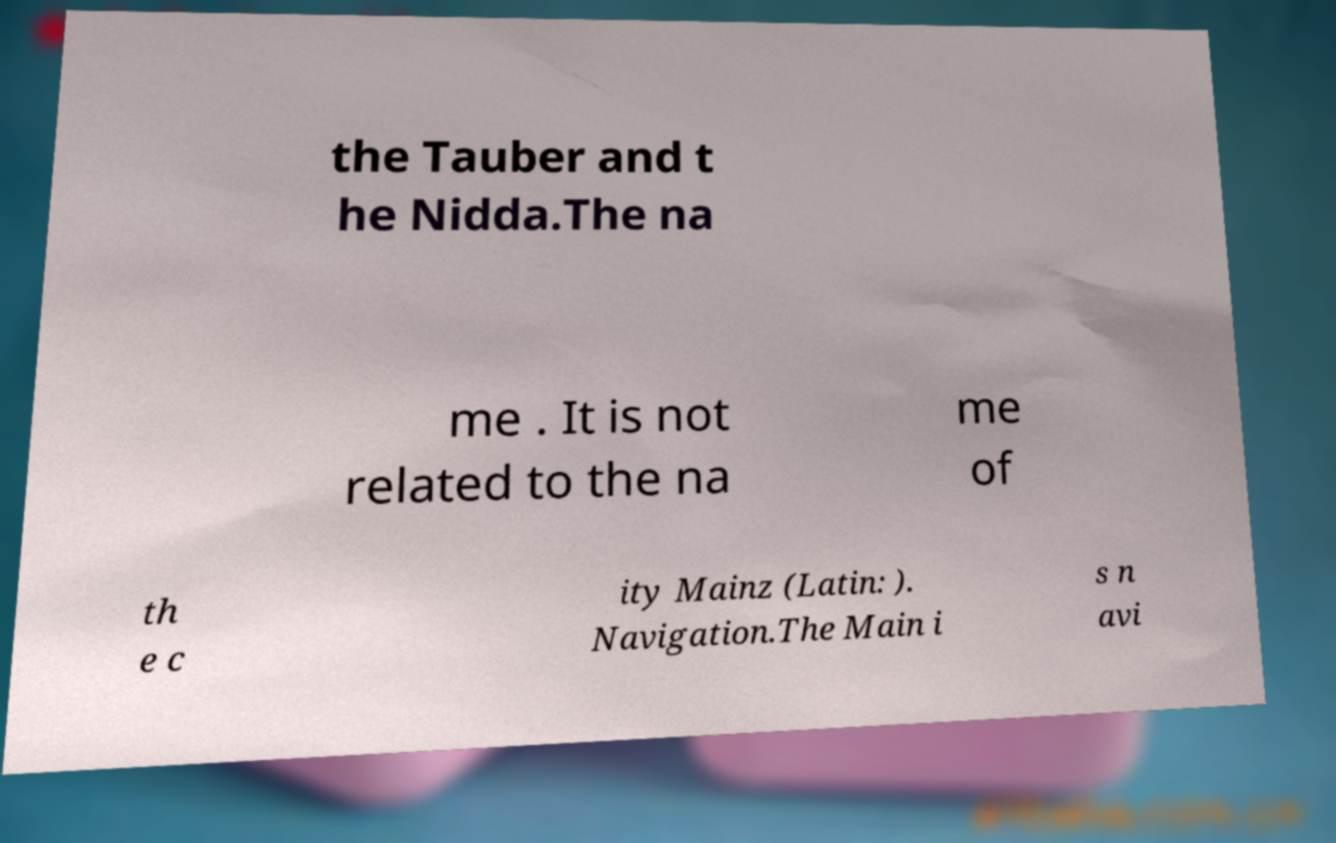I need the written content from this picture converted into text. Can you do that? the Tauber and t he Nidda.The na me . It is not related to the na me of th e c ity Mainz (Latin: ). Navigation.The Main i s n avi 